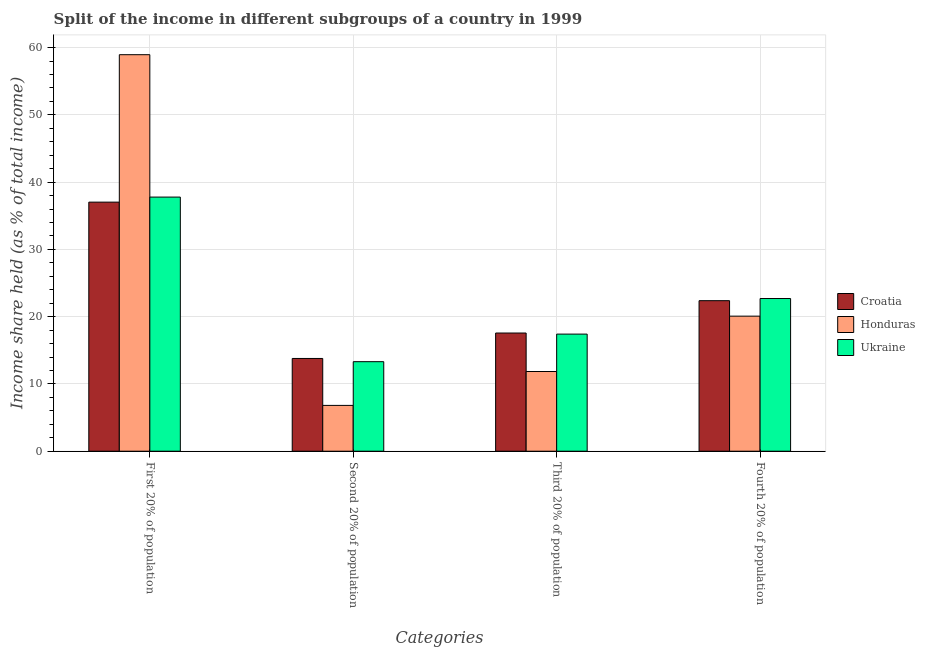Are the number of bars per tick equal to the number of legend labels?
Offer a very short reply. Yes. How many bars are there on the 1st tick from the left?
Make the answer very short. 3. What is the label of the 3rd group of bars from the left?
Your answer should be compact. Third 20% of population. What is the share of the income held by first 20% of the population in Croatia?
Offer a terse response. 37.03. Across all countries, what is the maximum share of the income held by third 20% of the population?
Provide a succinct answer. 17.57. Across all countries, what is the minimum share of the income held by third 20% of the population?
Give a very brief answer. 11.85. In which country was the share of the income held by second 20% of the population maximum?
Make the answer very short. Croatia. In which country was the share of the income held by fourth 20% of the population minimum?
Give a very brief answer. Honduras. What is the total share of the income held by first 20% of the population in the graph?
Give a very brief answer. 133.76. What is the difference between the share of the income held by third 20% of the population in Croatia and that in Ukraine?
Your answer should be very brief. 0.16. What is the difference between the share of the income held by third 20% of the population in Ukraine and the share of the income held by first 20% of the population in Honduras?
Make the answer very short. -41.54. What is the average share of the income held by first 20% of the population per country?
Keep it short and to the point. 44.59. What is the difference between the share of the income held by third 20% of the population and share of the income held by second 20% of the population in Croatia?
Offer a terse response. 3.78. In how many countries, is the share of the income held by second 20% of the population greater than 46 %?
Provide a short and direct response. 0. What is the ratio of the share of the income held by fourth 20% of the population in Honduras to that in Ukraine?
Offer a very short reply. 0.88. What is the difference between the highest and the second highest share of the income held by first 20% of the population?
Provide a succinct answer. 21.17. What is the difference between the highest and the lowest share of the income held by second 20% of the population?
Give a very brief answer. 6.98. In how many countries, is the share of the income held by second 20% of the population greater than the average share of the income held by second 20% of the population taken over all countries?
Give a very brief answer. 2. Is the sum of the share of the income held by second 20% of the population in Ukraine and Honduras greater than the maximum share of the income held by third 20% of the population across all countries?
Give a very brief answer. Yes. What does the 1st bar from the left in Fourth 20% of population represents?
Give a very brief answer. Croatia. What does the 2nd bar from the right in First 20% of population represents?
Ensure brevity in your answer.  Honduras. Is it the case that in every country, the sum of the share of the income held by first 20% of the population and share of the income held by second 20% of the population is greater than the share of the income held by third 20% of the population?
Provide a short and direct response. Yes. Are the values on the major ticks of Y-axis written in scientific E-notation?
Ensure brevity in your answer.  No. Where does the legend appear in the graph?
Offer a terse response. Center right. How many legend labels are there?
Make the answer very short. 3. How are the legend labels stacked?
Your response must be concise. Vertical. What is the title of the graph?
Your answer should be compact. Split of the income in different subgroups of a country in 1999. Does "Mauritania" appear as one of the legend labels in the graph?
Keep it short and to the point. No. What is the label or title of the X-axis?
Offer a very short reply. Categories. What is the label or title of the Y-axis?
Provide a succinct answer. Income share held (as % of total income). What is the Income share held (as % of total income) of Croatia in First 20% of population?
Your response must be concise. 37.03. What is the Income share held (as % of total income) in Honduras in First 20% of population?
Make the answer very short. 58.95. What is the Income share held (as % of total income) of Ukraine in First 20% of population?
Offer a very short reply. 37.78. What is the Income share held (as % of total income) in Croatia in Second 20% of population?
Provide a short and direct response. 13.79. What is the Income share held (as % of total income) of Honduras in Second 20% of population?
Offer a very short reply. 6.81. What is the Income share held (as % of total income) in Ukraine in Second 20% of population?
Your answer should be compact. 13.31. What is the Income share held (as % of total income) of Croatia in Third 20% of population?
Offer a terse response. 17.57. What is the Income share held (as % of total income) of Honduras in Third 20% of population?
Provide a short and direct response. 11.85. What is the Income share held (as % of total income) in Ukraine in Third 20% of population?
Make the answer very short. 17.41. What is the Income share held (as % of total income) of Croatia in Fourth 20% of population?
Your response must be concise. 22.38. What is the Income share held (as % of total income) in Honduras in Fourth 20% of population?
Ensure brevity in your answer.  20.08. What is the Income share held (as % of total income) of Ukraine in Fourth 20% of population?
Give a very brief answer. 22.7. Across all Categories, what is the maximum Income share held (as % of total income) in Croatia?
Keep it short and to the point. 37.03. Across all Categories, what is the maximum Income share held (as % of total income) of Honduras?
Your answer should be compact. 58.95. Across all Categories, what is the maximum Income share held (as % of total income) in Ukraine?
Make the answer very short. 37.78. Across all Categories, what is the minimum Income share held (as % of total income) of Croatia?
Keep it short and to the point. 13.79. Across all Categories, what is the minimum Income share held (as % of total income) of Honduras?
Make the answer very short. 6.81. Across all Categories, what is the minimum Income share held (as % of total income) of Ukraine?
Make the answer very short. 13.31. What is the total Income share held (as % of total income) in Croatia in the graph?
Ensure brevity in your answer.  90.77. What is the total Income share held (as % of total income) in Honduras in the graph?
Give a very brief answer. 97.69. What is the total Income share held (as % of total income) of Ukraine in the graph?
Offer a very short reply. 91.2. What is the difference between the Income share held (as % of total income) in Croatia in First 20% of population and that in Second 20% of population?
Provide a succinct answer. 23.24. What is the difference between the Income share held (as % of total income) of Honduras in First 20% of population and that in Second 20% of population?
Your answer should be very brief. 52.14. What is the difference between the Income share held (as % of total income) in Ukraine in First 20% of population and that in Second 20% of population?
Offer a very short reply. 24.47. What is the difference between the Income share held (as % of total income) of Croatia in First 20% of population and that in Third 20% of population?
Provide a succinct answer. 19.46. What is the difference between the Income share held (as % of total income) of Honduras in First 20% of population and that in Third 20% of population?
Provide a short and direct response. 47.1. What is the difference between the Income share held (as % of total income) in Ukraine in First 20% of population and that in Third 20% of population?
Offer a terse response. 20.37. What is the difference between the Income share held (as % of total income) of Croatia in First 20% of population and that in Fourth 20% of population?
Offer a very short reply. 14.65. What is the difference between the Income share held (as % of total income) in Honduras in First 20% of population and that in Fourth 20% of population?
Provide a short and direct response. 38.87. What is the difference between the Income share held (as % of total income) in Ukraine in First 20% of population and that in Fourth 20% of population?
Provide a succinct answer. 15.08. What is the difference between the Income share held (as % of total income) in Croatia in Second 20% of population and that in Third 20% of population?
Your answer should be compact. -3.78. What is the difference between the Income share held (as % of total income) in Honduras in Second 20% of population and that in Third 20% of population?
Offer a terse response. -5.04. What is the difference between the Income share held (as % of total income) of Ukraine in Second 20% of population and that in Third 20% of population?
Offer a very short reply. -4.1. What is the difference between the Income share held (as % of total income) of Croatia in Second 20% of population and that in Fourth 20% of population?
Keep it short and to the point. -8.59. What is the difference between the Income share held (as % of total income) in Honduras in Second 20% of population and that in Fourth 20% of population?
Provide a succinct answer. -13.27. What is the difference between the Income share held (as % of total income) of Ukraine in Second 20% of population and that in Fourth 20% of population?
Offer a terse response. -9.39. What is the difference between the Income share held (as % of total income) of Croatia in Third 20% of population and that in Fourth 20% of population?
Keep it short and to the point. -4.81. What is the difference between the Income share held (as % of total income) of Honduras in Third 20% of population and that in Fourth 20% of population?
Give a very brief answer. -8.23. What is the difference between the Income share held (as % of total income) of Ukraine in Third 20% of population and that in Fourth 20% of population?
Ensure brevity in your answer.  -5.29. What is the difference between the Income share held (as % of total income) of Croatia in First 20% of population and the Income share held (as % of total income) of Honduras in Second 20% of population?
Make the answer very short. 30.22. What is the difference between the Income share held (as % of total income) in Croatia in First 20% of population and the Income share held (as % of total income) in Ukraine in Second 20% of population?
Provide a succinct answer. 23.72. What is the difference between the Income share held (as % of total income) of Honduras in First 20% of population and the Income share held (as % of total income) of Ukraine in Second 20% of population?
Make the answer very short. 45.64. What is the difference between the Income share held (as % of total income) of Croatia in First 20% of population and the Income share held (as % of total income) of Honduras in Third 20% of population?
Provide a succinct answer. 25.18. What is the difference between the Income share held (as % of total income) of Croatia in First 20% of population and the Income share held (as % of total income) of Ukraine in Third 20% of population?
Keep it short and to the point. 19.62. What is the difference between the Income share held (as % of total income) in Honduras in First 20% of population and the Income share held (as % of total income) in Ukraine in Third 20% of population?
Make the answer very short. 41.54. What is the difference between the Income share held (as % of total income) in Croatia in First 20% of population and the Income share held (as % of total income) in Honduras in Fourth 20% of population?
Your answer should be compact. 16.95. What is the difference between the Income share held (as % of total income) of Croatia in First 20% of population and the Income share held (as % of total income) of Ukraine in Fourth 20% of population?
Give a very brief answer. 14.33. What is the difference between the Income share held (as % of total income) in Honduras in First 20% of population and the Income share held (as % of total income) in Ukraine in Fourth 20% of population?
Offer a terse response. 36.25. What is the difference between the Income share held (as % of total income) of Croatia in Second 20% of population and the Income share held (as % of total income) of Honduras in Third 20% of population?
Provide a succinct answer. 1.94. What is the difference between the Income share held (as % of total income) in Croatia in Second 20% of population and the Income share held (as % of total income) in Ukraine in Third 20% of population?
Keep it short and to the point. -3.62. What is the difference between the Income share held (as % of total income) in Honduras in Second 20% of population and the Income share held (as % of total income) in Ukraine in Third 20% of population?
Provide a succinct answer. -10.6. What is the difference between the Income share held (as % of total income) in Croatia in Second 20% of population and the Income share held (as % of total income) in Honduras in Fourth 20% of population?
Make the answer very short. -6.29. What is the difference between the Income share held (as % of total income) in Croatia in Second 20% of population and the Income share held (as % of total income) in Ukraine in Fourth 20% of population?
Your response must be concise. -8.91. What is the difference between the Income share held (as % of total income) of Honduras in Second 20% of population and the Income share held (as % of total income) of Ukraine in Fourth 20% of population?
Provide a short and direct response. -15.89. What is the difference between the Income share held (as % of total income) of Croatia in Third 20% of population and the Income share held (as % of total income) of Honduras in Fourth 20% of population?
Make the answer very short. -2.51. What is the difference between the Income share held (as % of total income) of Croatia in Third 20% of population and the Income share held (as % of total income) of Ukraine in Fourth 20% of population?
Keep it short and to the point. -5.13. What is the difference between the Income share held (as % of total income) in Honduras in Third 20% of population and the Income share held (as % of total income) in Ukraine in Fourth 20% of population?
Provide a short and direct response. -10.85. What is the average Income share held (as % of total income) of Croatia per Categories?
Provide a succinct answer. 22.69. What is the average Income share held (as % of total income) in Honduras per Categories?
Offer a very short reply. 24.42. What is the average Income share held (as % of total income) in Ukraine per Categories?
Keep it short and to the point. 22.8. What is the difference between the Income share held (as % of total income) of Croatia and Income share held (as % of total income) of Honduras in First 20% of population?
Offer a very short reply. -21.92. What is the difference between the Income share held (as % of total income) of Croatia and Income share held (as % of total income) of Ukraine in First 20% of population?
Make the answer very short. -0.75. What is the difference between the Income share held (as % of total income) in Honduras and Income share held (as % of total income) in Ukraine in First 20% of population?
Ensure brevity in your answer.  21.17. What is the difference between the Income share held (as % of total income) of Croatia and Income share held (as % of total income) of Honduras in Second 20% of population?
Provide a succinct answer. 6.98. What is the difference between the Income share held (as % of total income) in Croatia and Income share held (as % of total income) in Ukraine in Second 20% of population?
Provide a succinct answer. 0.48. What is the difference between the Income share held (as % of total income) of Honduras and Income share held (as % of total income) of Ukraine in Second 20% of population?
Provide a short and direct response. -6.5. What is the difference between the Income share held (as % of total income) in Croatia and Income share held (as % of total income) in Honduras in Third 20% of population?
Make the answer very short. 5.72. What is the difference between the Income share held (as % of total income) in Croatia and Income share held (as % of total income) in Ukraine in Third 20% of population?
Provide a succinct answer. 0.16. What is the difference between the Income share held (as % of total income) of Honduras and Income share held (as % of total income) of Ukraine in Third 20% of population?
Make the answer very short. -5.56. What is the difference between the Income share held (as % of total income) of Croatia and Income share held (as % of total income) of Honduras in Fourth 20% of population?
Make the answer very short. 2.3. What is the difference between the Income share held (as % of total income) in Croatia and Income share held (as % of total income) in Ukraine in Fourth 20% of population?
Offer a very short reply. -0.32. What is the difference between the Income share held (as % of total income) in Honduras and Income share held (as % of total income) in Ukraine in Fourth 20% of population?
Provide a succinct answer. -2.62. What is the ratio of the Income share held (as % of total income) of Croatia in First 20% of population to that in Second 20% of population?
Your answer should be very brief. 2.69. What is the ratio of the Income share held (as % of total income) of Honduras in First 20% of population to that in Second 20% of population?
Offer a terse response. 8.66. What is the ratio of the Income share held (as % of total income) of Ukraine in First 20% of population to that in Second 20% of population?
Make the answer very short. 2.84. What is the ratio of the Income share held (as % of total income) of Croatia in First 20% of population to that in Third 20% of population?
Offer a terse response. 2.11. What is the ratio of the Income share held (as % of total income) in Honduras in First 20% of population to that in Third 20% of population?
Offer a very short reply. 4.97. What is the ratio of the Income share held (as % of total income) of Ukraine in First 20% of population to that in Third 20% of population?
Provide a short and direct response. 2.17. What is the ratio of the Income share held (as % of total income) in Croatia in First 20% of population to that in Fourth 20% of population?
Ensure brevity in your answer.  1.65. What is the ratio of the Income share held (as % of total income) in Honduras in First 20% of population to that in Fourth 20% of population?
Ensure brevity in your answer.  2.94. What is the ratio of the Income share held (as % of total income) in Ukraine in First 20% of population to that in Fourth 20% of population?
Your response must be concise. 1.66. What is the ratio of the Income share held (as % of total income) in Croatia in Second 20% of population to that in Third 20% of population?
Your answer should be very brief. 0.78. What is the ratio of the Income share held (as % of total income) in Honduras in Second 20% of population to that in Third 20% of population?
Ensure brevity in your answer.  0.57. What is the ratio of the Income share held (as % of total income) in Ukraine in Second 20% of population to that in Third 20% of population?
Make the answer very short. 0.76. What is the ratio of the Income share held (as % of total income) of Croatia in Second 20% of population to that in Fourth 20% of population?
Ensure brevity in your answer.  0.62. What is the ratio of the Income share held (as % of total income) of Honduras in Second 20% of population to that in Fourth 20% of population?
Give a very brief answer. 0.34. What is the ratio of the Income share held (as % of total income) in Ukraine in Second 20% of population to that in Fourth 20% of population?
Offer a terse response. 0.59. What is the ratio of the Income share held (as % of total income) of Croatia in Third 20% of population to that in Fourth 20% of population?
Your answer should be very brief. 0.79. What is the ratio of the Income share held (as % of total income) in Honduras in Third 20% of population to that in Fourth 20% of population?
Keep it short and to the point. 0.59. What is the ratio of the Income share held (as % of total income) of Ukraine in Third 20% of population to that in Fourth 20% of population?
Provide a short and direct response. 0.77. What is the difference between the highest and the second highest Income share held (as % of total income) of Croatia?
Your answer should be very brief. 14.65. What is the difference between the highest and the second highest Income share held (as % of total income) in Honduras?
Your answer should be compact. 38.87. What is the difference between the highest and the second highest Income share held (as % of total income) in Ukraine?
Give a very brief answer. 15.08. What is the difference between the highest and the lowest Income share held (as % of total income) in Croatia?
Offer a very short reply. 23.24. What is the difference between the highest and the lowest Income share held (as % of total income) of Honduras?
Your response must be concise. 52.14. What is the difference between the highest and the lowest Income share held (as % of total income) in Ukraine?
Your answer should be very brief. 24.47. 